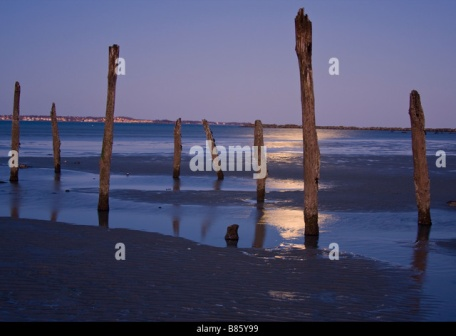If an artist were to paint this scene, what elements would they focus on? An artist painting this scene would likely focus on the contrast between the solid, weathered wooden poles and the fluid, reflective water surrounding their bases. They would capture the serene hues of dusk, with gradients of blue and hints of sunlight playing off the wet sand and water. The interplay of light and shadow, as well as the reflections of the poles in the shallow pools, would be crucial elements, creating a captivating and tranquil composition that evokes a sense of timeless beauty and quiet solitude. 